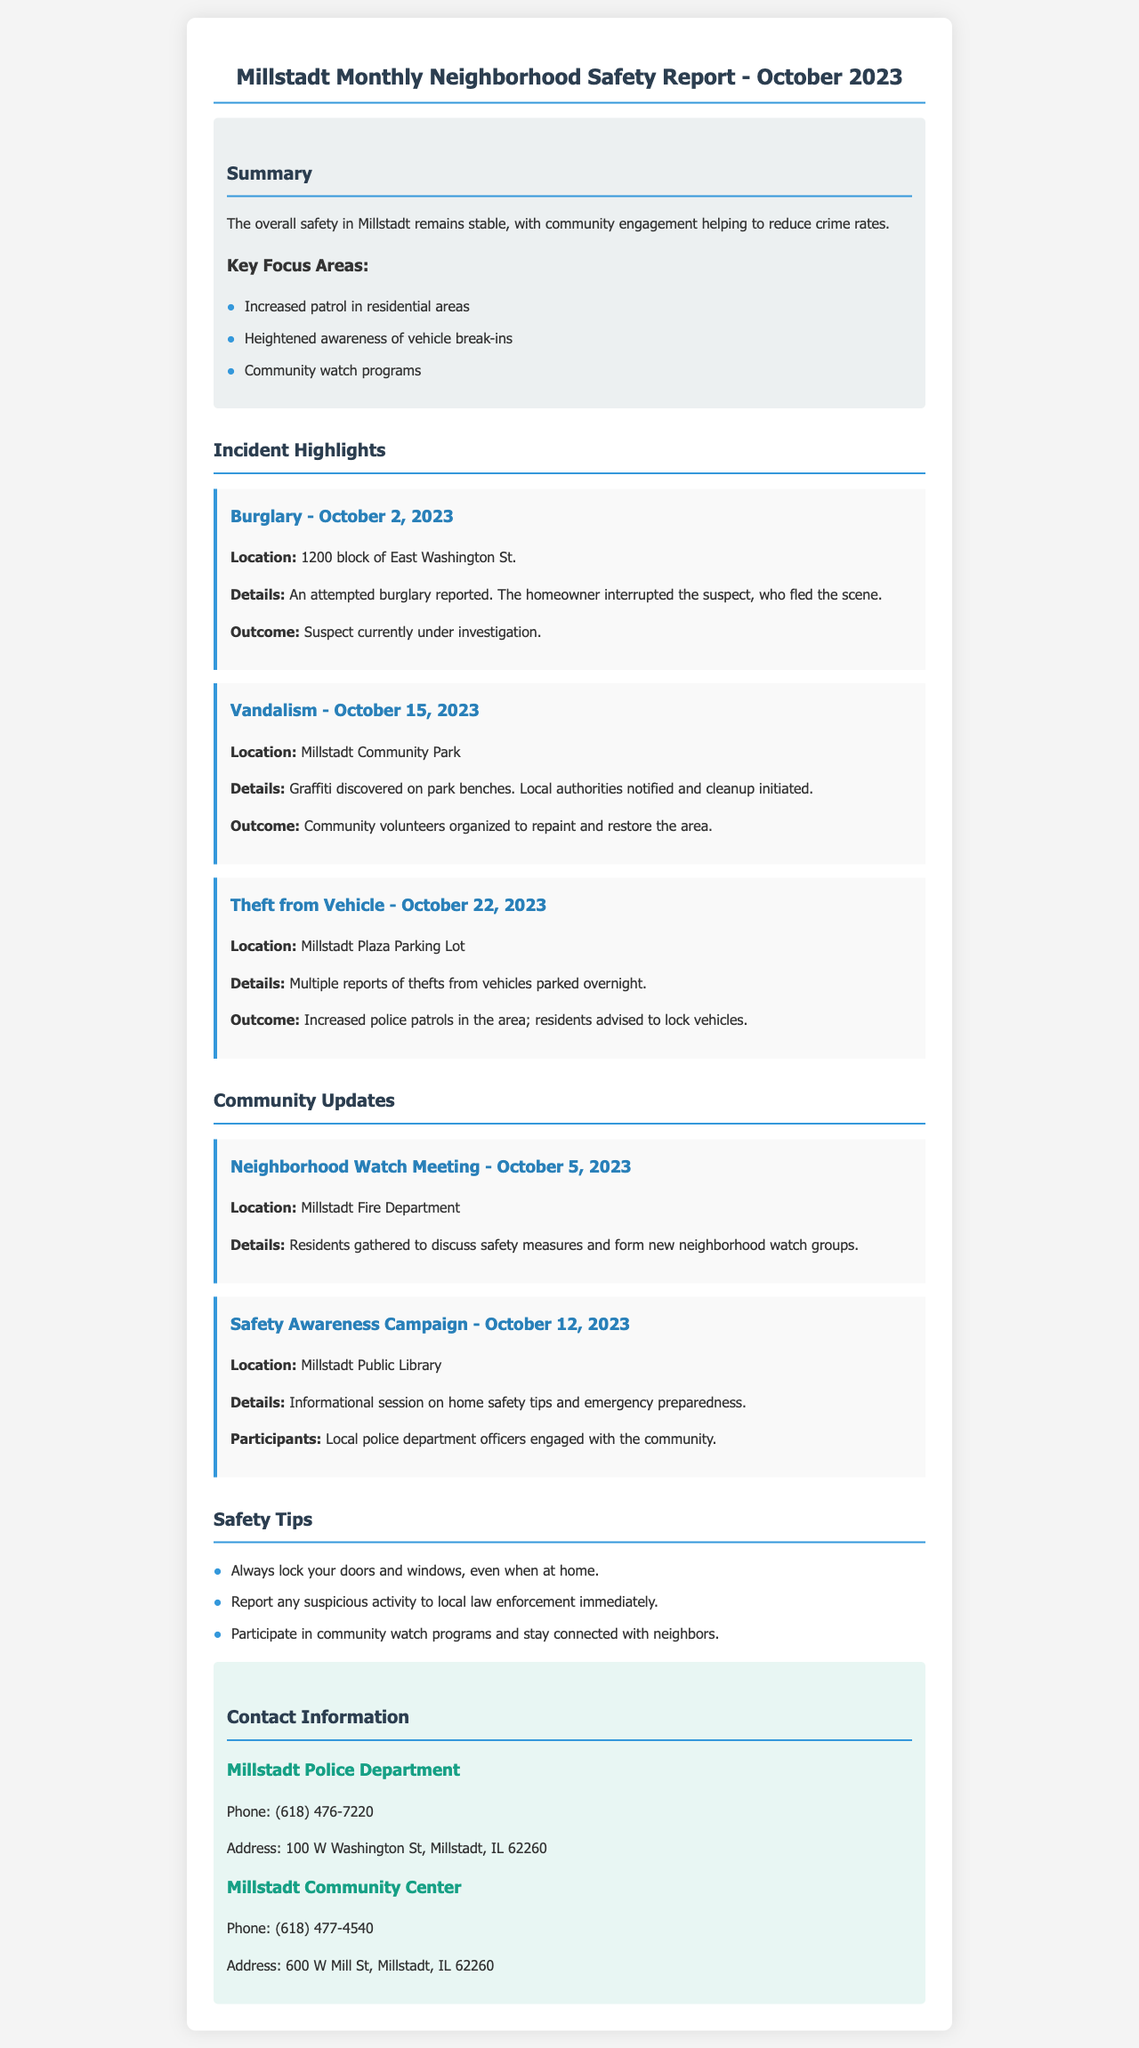What is the date of the burglary incident? The date of the burglary incident is mentioned in the incident section of the report.
Answer: October 2, 2023 Where did the vandalism occur? The location of the vandalism is specified under the incident highlights in the document.
Answer: Millstadt Community Park Who organized the repainting after the vandalism? The responsibility for repainting and restoring the area after the vandalism is found in the details section of the incident report.
Answer: Community volunteers What was the main topic of the safety awareness campaign? The document lists details about different community updates, including the main topics discussed at the events.
Answer: Home safety tips When was the Neighborhood Watch Meeting held? The date of the Neighborhood Watch Meeting is found in the community updates section of the report.
Answer: October 5, 2023 What safety tip recommends locking doors? The document provides a list of safety tips at the end, one of which suggests a particular action.
Answer: Always lock your doors and windows, even when at home How many theft incidents were reported in the Millstadt Plaza Parking Lot? The summary of the incident highlights shows multiple instances of thefts that were reported in a specific area.
Answer: Multiple What is the phone number for the Millstadt Police Department? The contact information section of the report lists essential contact details for different local services.
Answer: (618) 476-7220 What community center's phone number is listed in the report? The report includes contact details for two local organizations, one of which is specified.
Answer: (618) 477-4540 